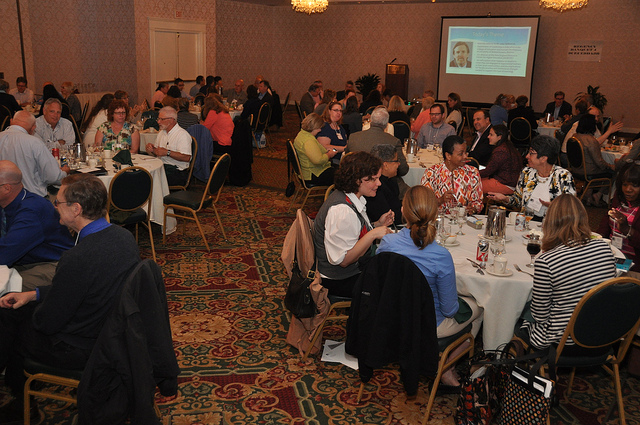What kind of event might this be? This appears to be a professional or formal gathering, possibly a conference or banquet, indicated by the orderly setup of the tables, the projector screen in the background, and the attire of the attendees. Are there any presentations or speeches being made? While a projector screen is visible in the background, suggesting that a presentation might occur, there is no one actively presenting or giving a speech in the image at this moment. 